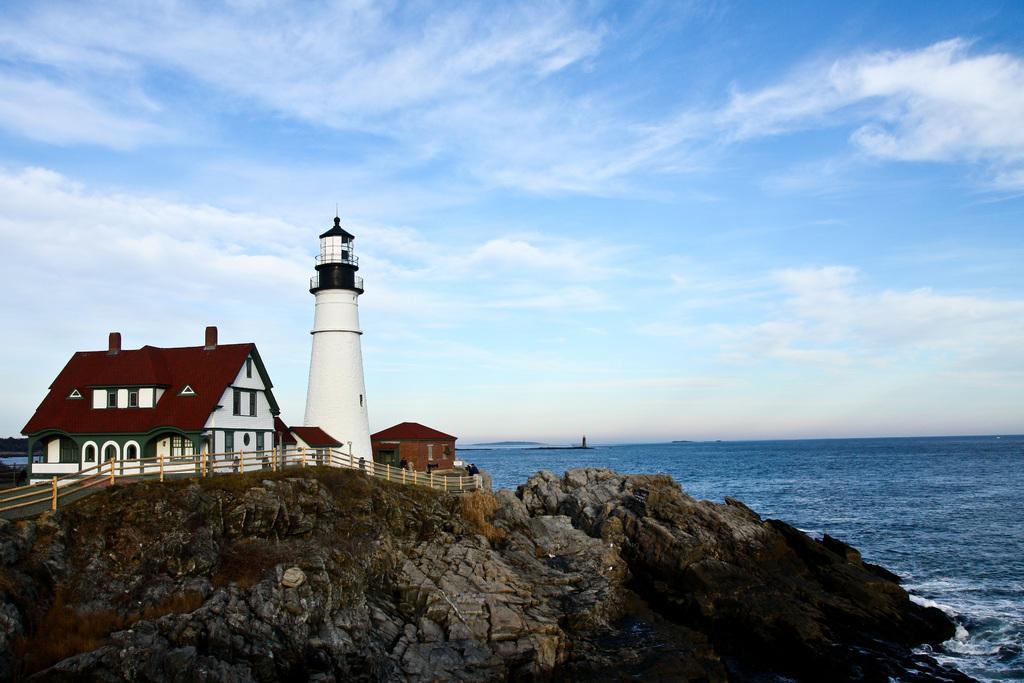Can you describe this image briefly? In this image, we can see some houses and a light house. We can see some rocks and water. We can see the fence and the sky with clouds. 